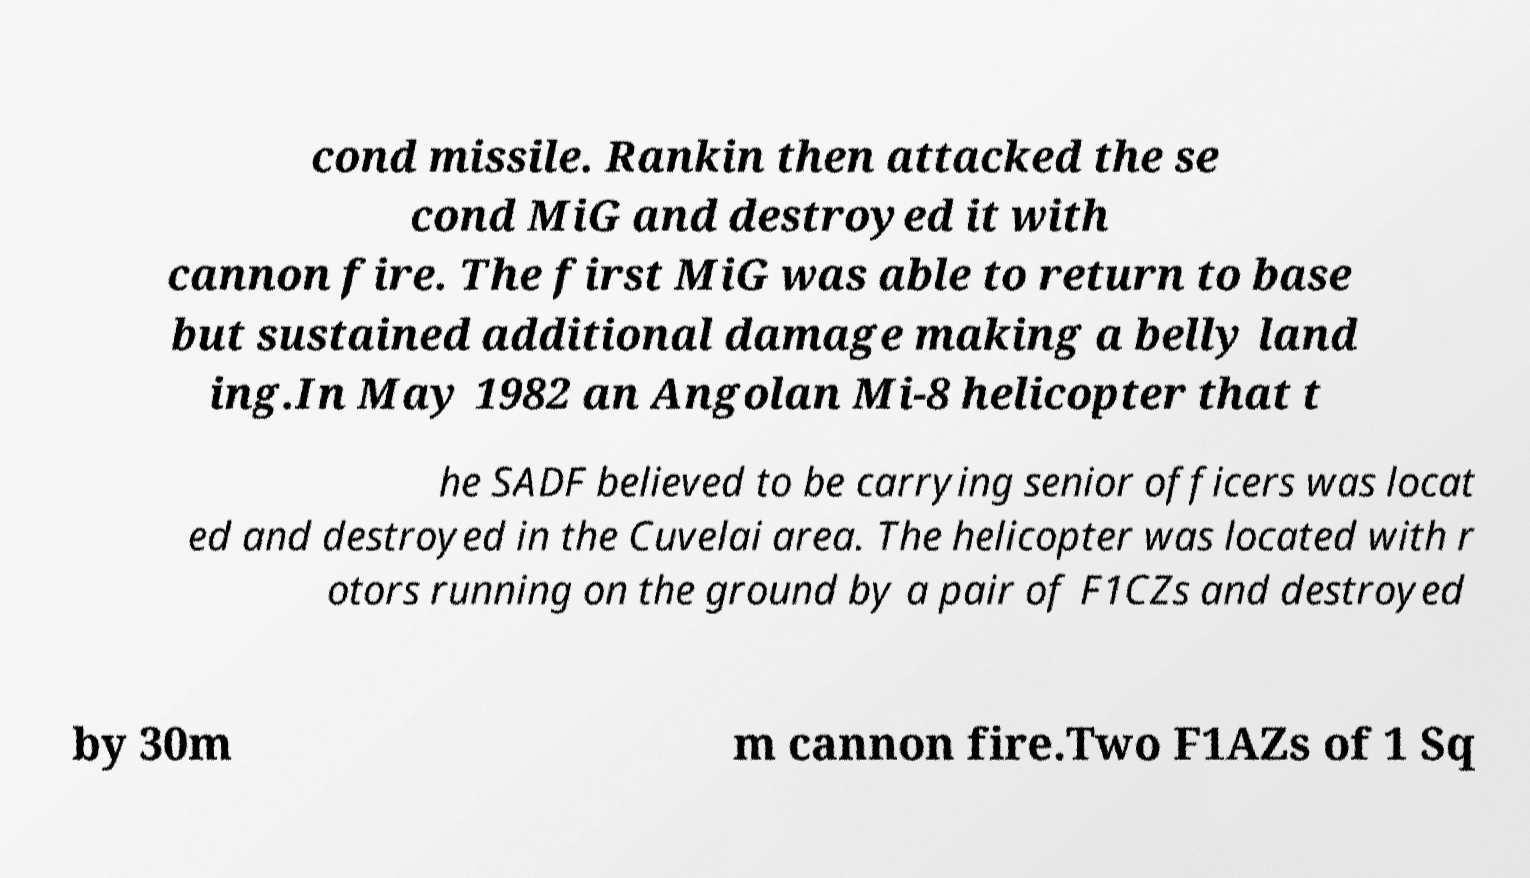What messages or text are displayed in this image? I need them in a readable, typed format. cond missile. Rankin then attacked the se cond MiG and destroyed it with cannon fire. The first MiG was able to return to base but sustained additional damage making a belly land ing.In May 1982 an Angolan Mi-8 helicopter that t he SADF believed to be carrying senior officers was locat ed and destroyed in the Cuvelai area. The helicopter was located with r otors running on the ground by a pair of F1CZs and destroyed by 30m m cannon fire.Two F1AZs of 1 Sq 